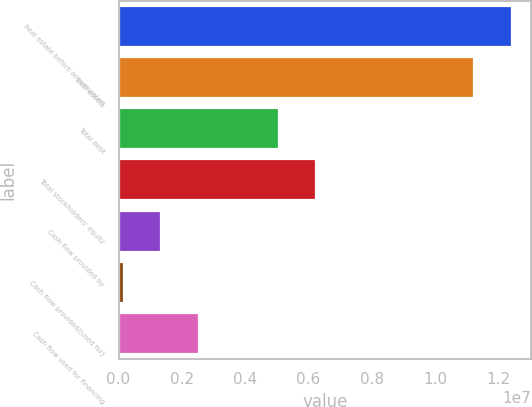Convert chart. <chart><loc_0><loc_0><loc_500><loc_500><bar_chart><fcel>Real estate before accumulated<fcel>Total assets<fcel>Total debt<fcel>Total stockholders' equity<fcel>Cash flow provided by<fcel>Cash flow provided/(used for)<fcel>Cash flow used for financing<nl><fcel>1.24149e+07<fcel>1.12306e+07<fcel>5.06637e+06<fcel>6.25064e+06<fcel>1.34965e+06<fcel>165383<fcel>2.53392e+06<nl></chart> 